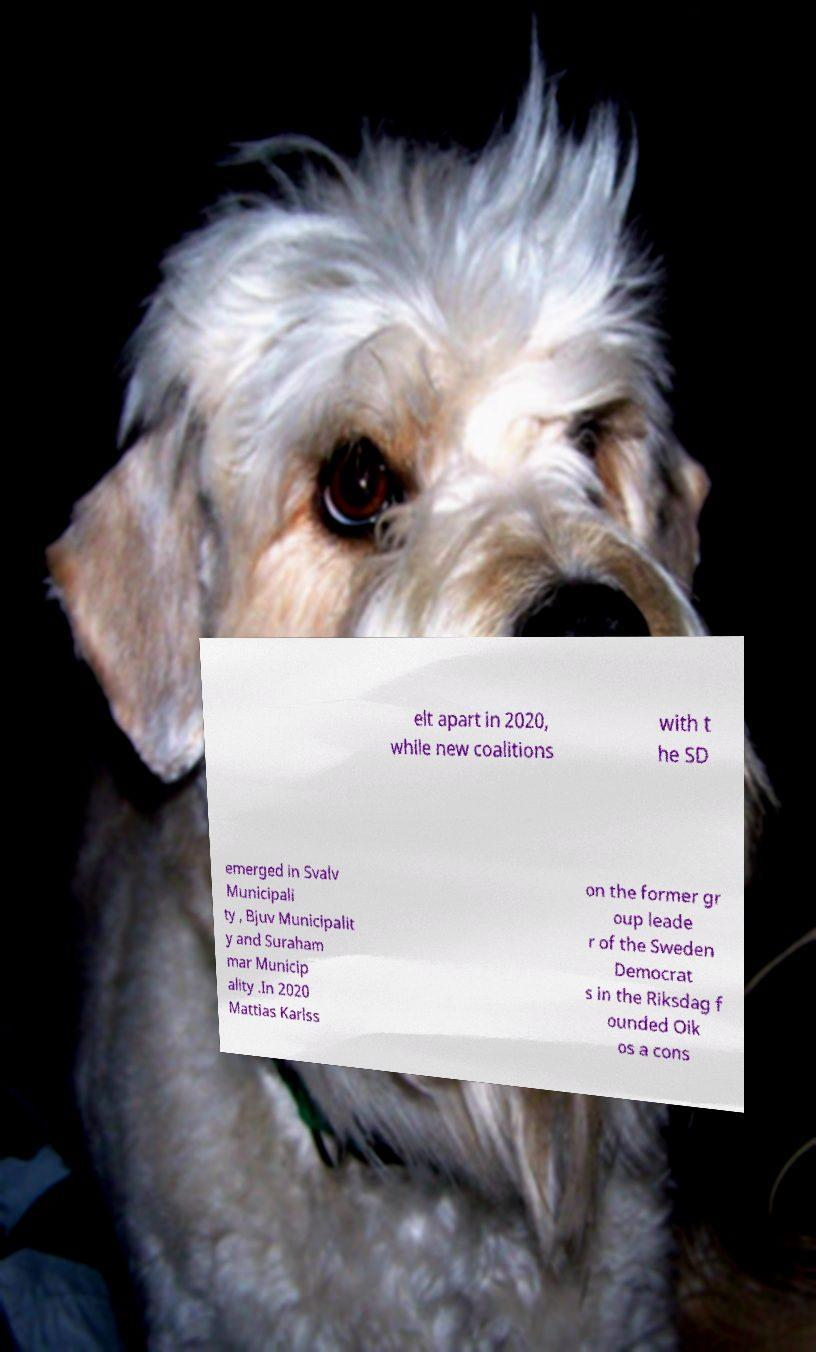I need the written content from this picture converted into text. Can you do that? elt apart in 2020, while new coalitions with t he SD emerged in Svalv Municipali ty , Bjuv Municipalit y and Suraham mar Municip ality .In 2020 Mattias Karlss on the former gr oup leade r of the Sweden Democrat s in the Riksdag f ounded Oik os a cons 